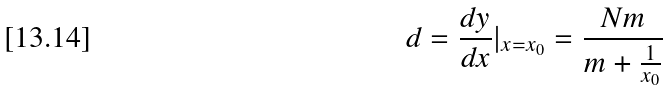Convert formula to latex. <formula><loc_0><loc_0><loc_500><loc_500>d = \frac { d y } { d x } | _ { x = x _ { 0 } } = \frac { N m } { m + \frac { 1 } { x _ { 0 } } }</formula> 